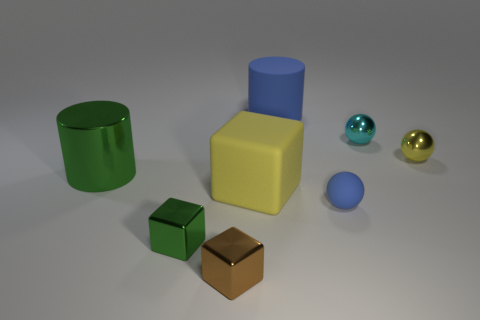Add 2 big green shiny cylinders. How many objects exist? 10 Subtract all yellow cubes. How many cubes are left? 2 Subtract all shiny cubes. How many cubes are left? 1 Subtract all balls. How many objects are left? 5 Subtract 2 cylinders. How many cylinders are left? 0 Add 3 small brown objects. How many small brown objects are left? 4 Add 4 big green cubes. How many big green cubes exist? 4 Subtract 1 yellow blocks. How many objects are left? 7 Subtract all cyan balls. Subtract all gray blocks. How many balls are left? 2 Subtract all gray cubes. How many red cylinders are left? 0 